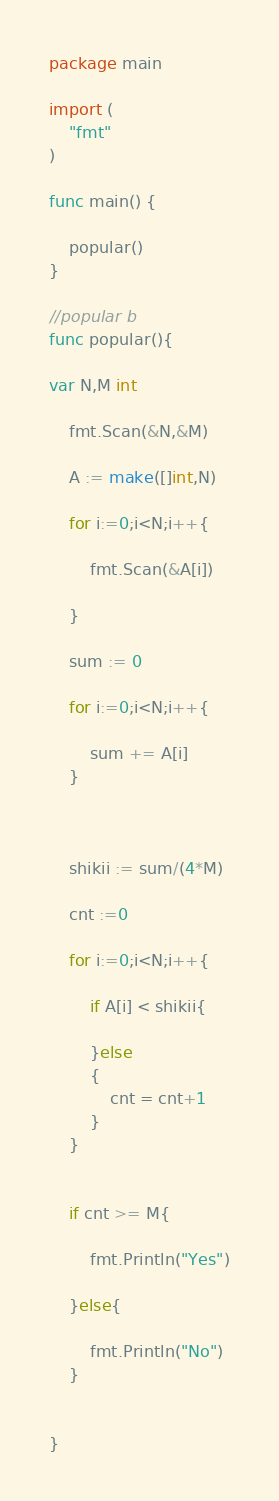<code> <loc_0><loc_0><loc_500><loc_500><_Go_>package main

import (
	"fmt"
)

func main() {

	popular()
}

//popular b
func popular(){

var N,M int

	fmt.Scan(&N,&M)

	A := make([]int,N)

	for i:=0;i<N;i++{

		fmt.Scan(&A[i])

	}

	sum := 0

	for i:=0;i<N;i++{

		sum += A[i]
	}



	shikii := sum/(4*M)

	cnt :=0

	for i:=0;i<N;i++{

		if A[i] < shikii{
			
		}else
		{
			cnt = cnt+1
		}
	}


	if cnt >= M{

		fmt.Println("Yes")

	}else{

		fmt.Println("No")
	}


}
</code> 